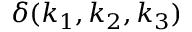Convert formula to latex. <formula><loc_0><loc_0><loc_500><loc_500>\delta ( k _ { 1 } , k _ { 2 } , k _ { 3 } )</formula> 